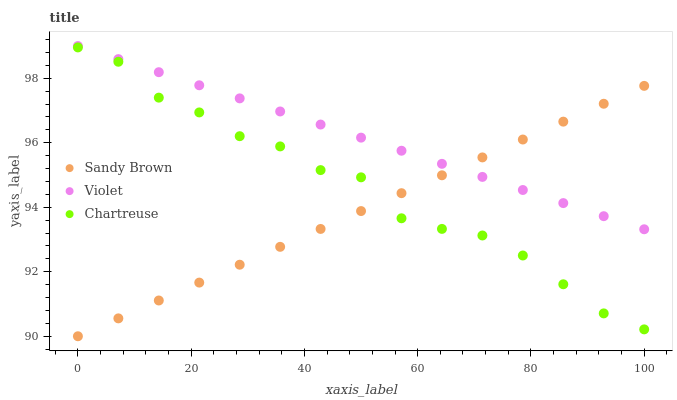Does Sandy Brown have the minimum area under the curve?
Answer yes or no. Yes. Does Violet have the maximum area under the curve?
Answer yes or no. Yes. Does Violet have the minimum area under the curve?
Answer yes or no. No. Does Sandy Brown have the maximum area under the curve?
Answer yes or no. No. Is Sandy Brown the smoothest?
Answer yes or no. Yes. Is Chartreuse the roughest?
Answer yes or no. Yes. Is Violet the smoothest?
Answer yes or no. No. Is Violet the roughest?
Answer yes or no. No. Does Sandy Brown have the lowest value?
Answer yes or no. Yes. Does Violet have the lowest value?
Answer yes or no. No. Does Violet have the highest value?
Answer yes or no. Yes. Does Sandy Brown have the highest value?
Answer yes or no. No. Is Chartreuse less than Violet?
Answer yes or no. Yes. Is Violet greater than Chartreuse?
Answer yes or no. Yes. Does Chartreuse intersect Sandy Brown?
Answer yes or no. Yes. Is Chartreuse less than Sandy Brown?
Answer yes or no. No. Is Chartreuse greater than Sandy Brown?
Answer yes or no. No. Does Chartreuse intersect Violet?
Answer yes or no. No. 